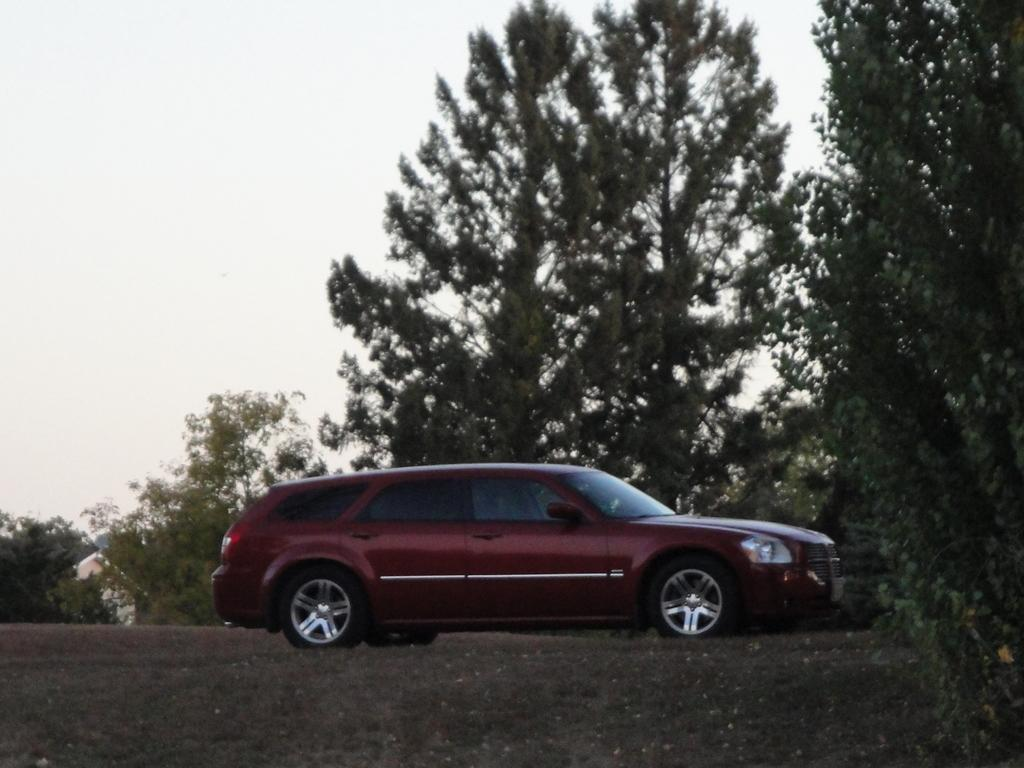What is the main subject of the image? The main subject of the image is a car. Can you describe the color of the car? The car is red. What can be seen in the background of the image? There are trees in the background of the image. How many pages does the cast of the car have in the image? There is no cast or pages present in the image; it features a red car with trees in the background. 